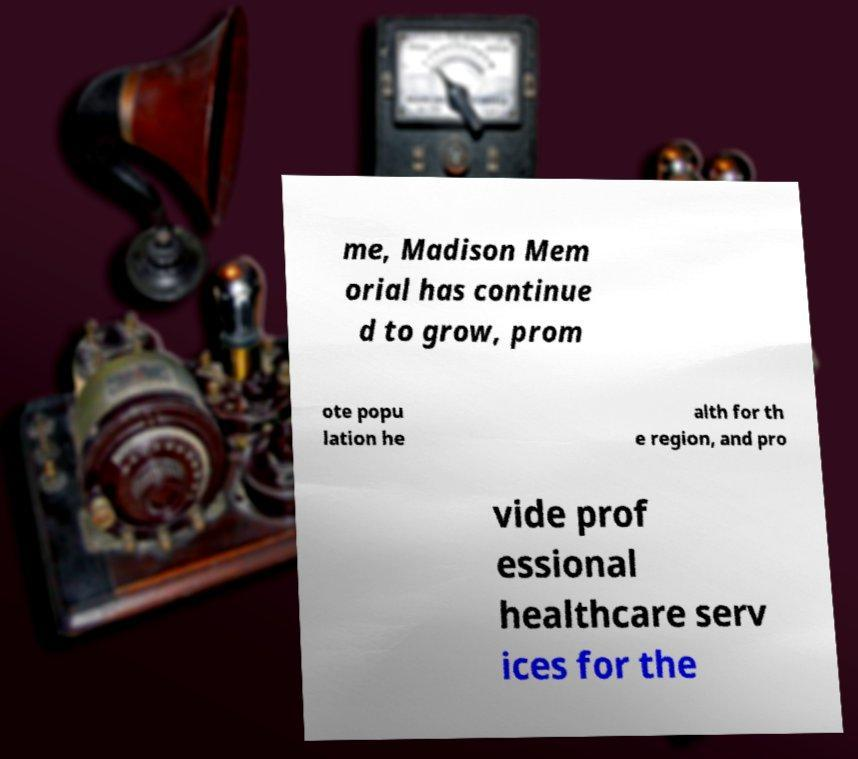I need the written content from this picture converted into text. Can you do that? me, Madison Mem orial has continue d to grow, prom ote popu lation he alth for th e region, and pro vide prof essional healthcare serv ices for the 